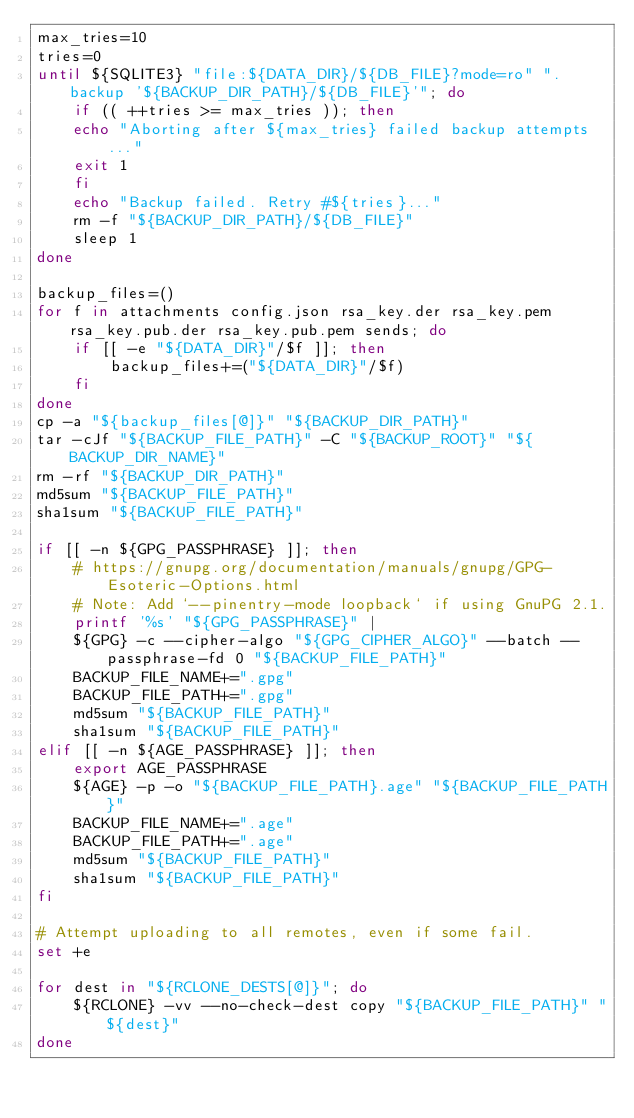Convert code to text. <code><loc_0><loc_0><loc_500><loc_500><_Bash_>max_tries=10
tries=0
until ${SQLITE3} "file:${DATA_DIR}/${DB_FILE}?mode=ro" ".backup '${BACKUP_DIR_PATH}/${DB_FILE}'"; do
    if (( ++tries >= max_tries )); then
	echo "Aborting after ${max_tries} failed backup attempts..."
	exit 1
    fi
    echo "Backup failed. Retry #${tries}..."
    rm -f "${BACKUP_DIR_PATH}/${DB_FILE}"
    sleep 1
done

backup_files=()
for f in attachments config.json rsa_key.der rsa_key.pem rsa_key.pub.der rsa_key.pub.pem sends; do
    if [[ -e "${DATA_DIR}"/$f ]]; then
        backup_files+=("${DATA_DIR}"/$f)
    fi
done
cp -a "${backup_files[@]}" "${BACKUP_DIR_PATH}"
tar -cJf "${BACKUP_FILE_PATH}" -C "${BACKUP_ROOT}" "${BACKUP_DIR_NAME}"
rm -rf "${BACKUP_DIR_PATH}"
md5sum "${BACKUP_FILE_PATH}"
sha1sum "${BACKUP_FILE_PATH}"

if [[ -n ${GPG_PASSPHRASE} ]]; then
    # https://gnupg.org/documentation/manuals/gnupg/GPG-Esoteric-Options.html
    # Note: Add `--pinentry-mode loopback` if using GnuPG 2.1.
    printf '%s' "${GPG_PASSPHRASE}" |
    ${GPG} -c --cipher-algo "${GPG_CIPHER_ALGO}" --batch --passphrase-fd 0 "${BACKUP_FILE_PATH}"
    BACKUP_FILE_NAME+=".gpg"
    BACKUP_FILE_PATH+=".gpg"
    md5sum "${BACKUP_FILE_PATH}"
    sha1sum "${BACKUP_FILE_PATH}"
elif [[ -n ${AGE_PASSPHRASE} ]]; then
    export AGE_PASSPHRASE
    ${AGE} -p -o "${BACKUP_FILE_PATH}.age" "${BACKUP_FILE_PATH}"
    BACKUP_FILE_NAME+=".age"
    BACKUP_FILE_PATH+=".age"
    md5sum "${BACKUP_FILE_PATH}"
    sha1sum "${BACKUP_FILE_PATH}"
fi

# Attempt uploading to all remotes, even if some fail.
set +e

for dest in "${RCLONE_DESTS[@]}"; do
    ${RCLONE} -vv --no-check-dest copy "${BACKUP_FILE_PATH}" "${dest}"
done
</code> 